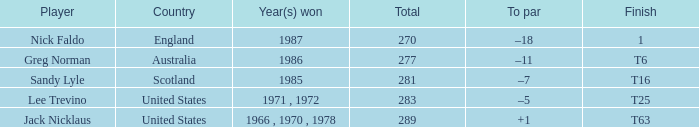How many sums conclude with t6 as the finishing outcome? 277.0. 